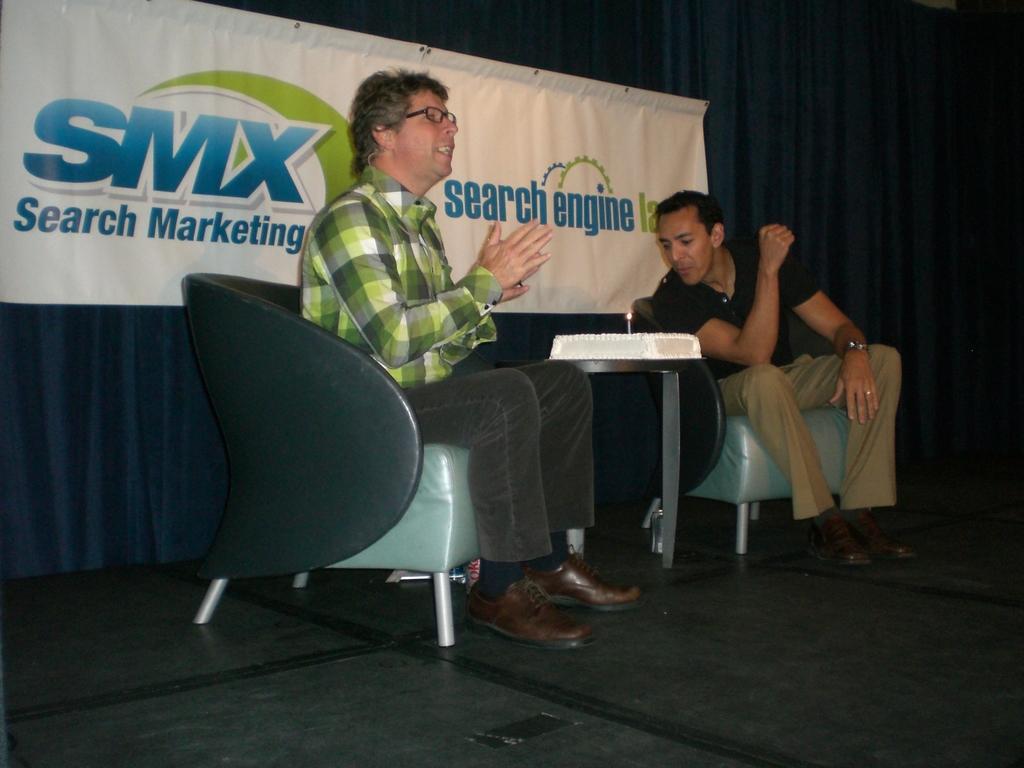How would you summarize this image in a sentence or two? In this image i can see two men who are sitting on a chair and talking. In the middle we have a cake on the table. 